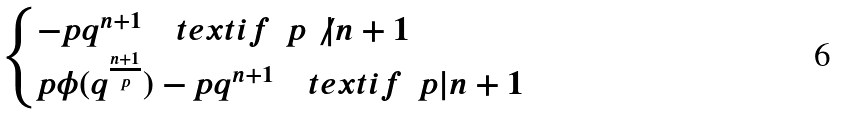<formula> <loc_0><loc_0><loc_500><loc_500>\begin{cases} - p q ^ { n + 1 } \quad t e x t { i f } \ \ p \not | n + 1 \\ p \phi ( q ^ { \frac { n + 1 } { p } } ) - p q ^ { n + 1 } \quad t e x t { i f } \ \ p | n + 1 \end{cases}</formula> 